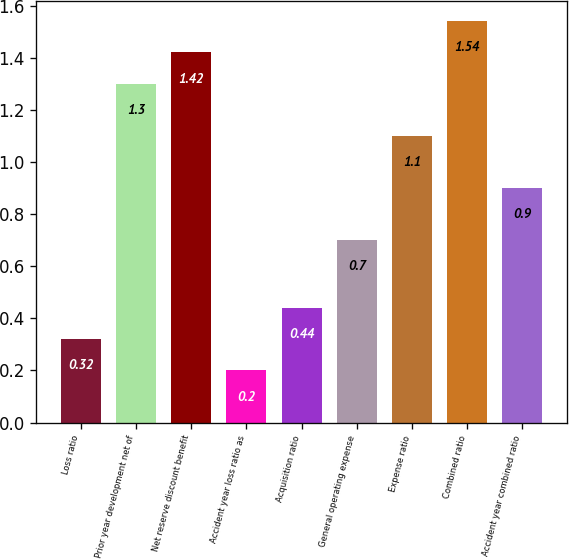Convert chart. <chart><loc_0><loc_0><loc_500><loc_500><bar_chart><fcel>Loss ratio<fcel>Prior year development net of<fcel>Net reserve discount benefit<fcel>Accident year loss ratio as<fcel>Acquisition ratio<fcel>General operating expense<fcel>Expense ratio<fcel>Combined ratio<fcel>Accident year combined ratio<nl><fcel>0.32<fcel>1.3<fcel>1.42<fcel>0.2<fcel>0.44<fcel>0.7<fcel>1.1<fcel>1.54<fcel>0.9<nl></chart> 